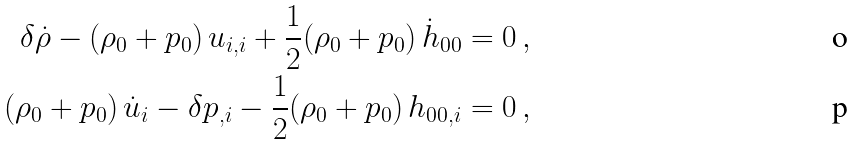<formula> <loc_0><loc_0><loc_500><loc_500>\delta \dot { \rho } - ( \rho _ { 0 } + p _ { 0 } ) \, u _ { i , i } + \frac { 1 } { 2 } ( \rho _ { 0 } + p _ { 0 } ) \, \dot { h } _ { 0 0 } & = 0 \, , \\ ( \rho _ { 0 } + p _ { 0 } ) \, \dot { u } _ { i } - \delta p _ { , i } - \frac { 1 } { 2 } ( \rho _ { 0 } + p _ { 0 } ) \, h _ { 0 0 , i } & = 0 \, ,</formula> 